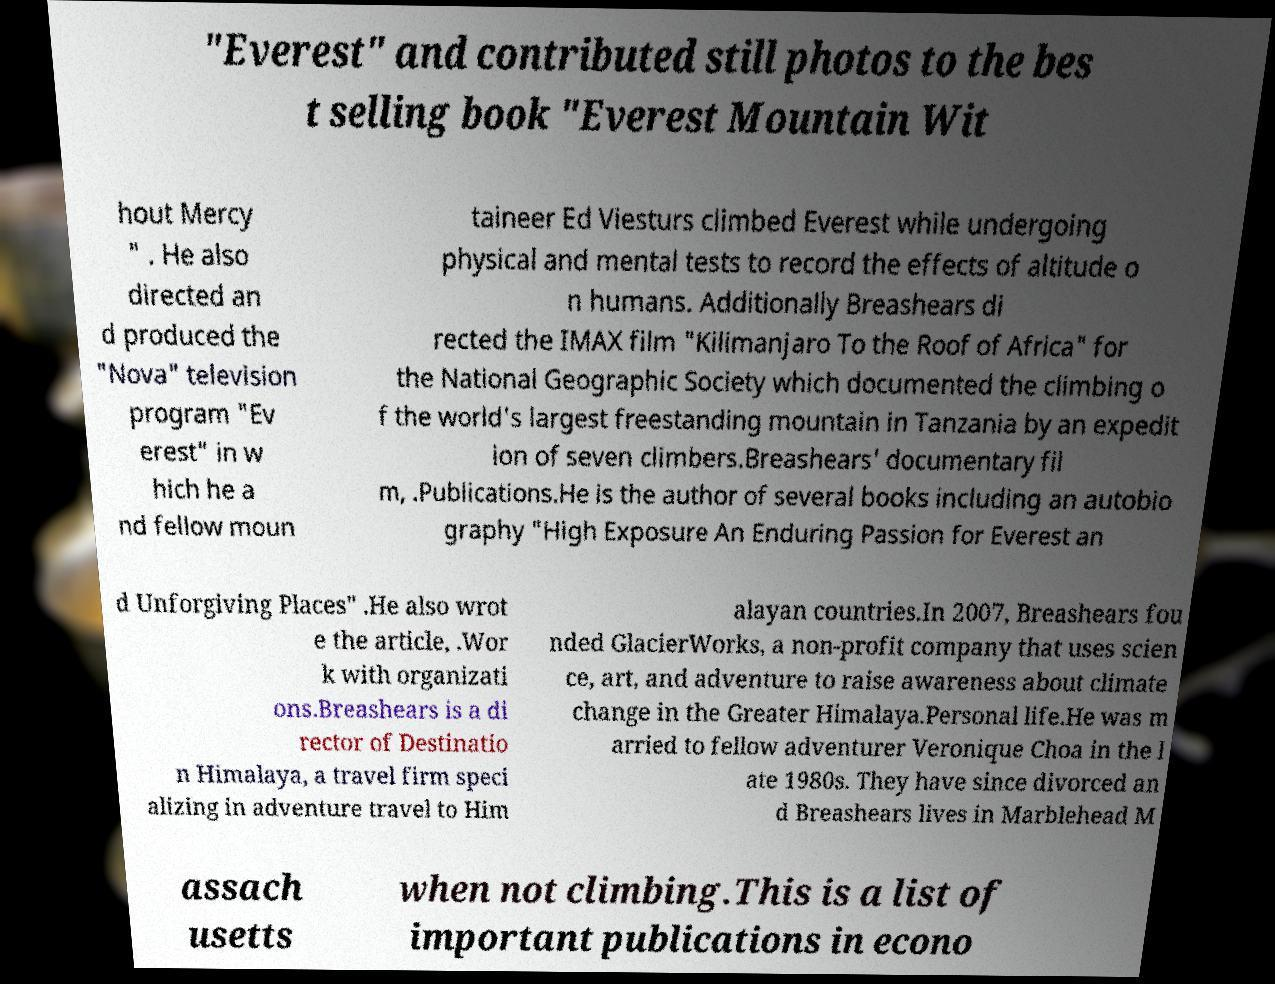I need the written content from this picture converted into text. Can you do that? "Everest" and contributed still photos to the bes t selling book "Everest Mountain Wit hout Mercy " . He also directed an d produced the "Nova" television program "Ev erest" in w hich he a nd fellow moun taineer Ed Viesturs climbed Everest while undergoing physical and mental tests to record the effects of altitude o n humans. Additionally Breashears di rected the IMAX film "Kilimanjaro To the Roof of Africa" for the National Geographic Society which documented the climbing o f the world's largest freestanding mountain in Tanzania by an expedit ion of seven climbers.Breashears' documentary fil m, .Publications.He is the author of several books including an autobio graphy "High Exposure An Enduring Passion for Everest an d Unforgiving Places" .He also wrot e the article, .Wor k with organizati ons.Breashears is a di rector of Destinatio n Himalaya, a travel firm speci alizing in adventure travel to Him alayan countries.In 2007, Breashears fou nded GlacierWorks, a non-profit company that uses scien ce, art, and adventure to raise awareness about climate change in the Greater Himalaya.Personal life.He was m arried to fellow adventurer Veronique Choa in the l ate 1980s. They have since divorced an d Breashears lives in Marblehead M assach usetts when not climbing.This is a list of important publications in econo 